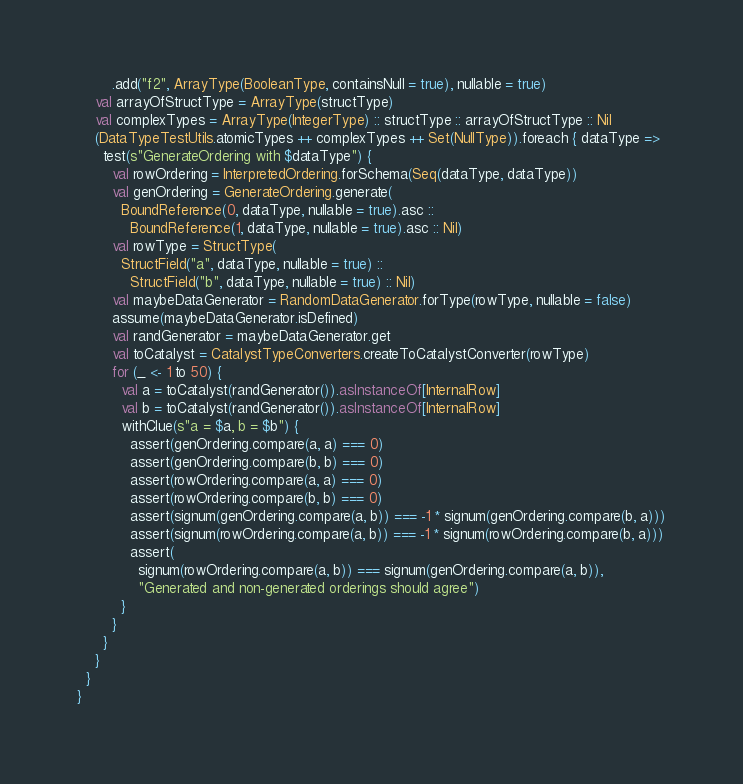<code> <loc_0><loc_0><loc_500><loc_500><_Scala_>        .add("f2", ArrayType(BooleanType, containsNull = true), nullable = true)
    val arrayOfStructType = ArrayType(structType)
    val complexTypes = ArrayType(IntegerType) :: structType :: arrayOfStructType :: Nil
    (DataTypeTestUtils.atomicTypes ++ complexTypes ++ Set(NullType)).foreach { dataType =>
      test(s"GenerateOrdering with $dataType") {
        val rowOrdering = InterpretedOrdering.forSchema(Seq(dataType, dataType))
        val genOrdering = GenerateOrdering.generate(
          BoundReference(0, dataType, nullable = true).asc ::
            BoundReference(1, dataType, nullable = true).asc :: Nil)
        val rowType = StructType(
          StructField("a", dataType, nullable = true) ::
            StructField("b", dataType, nullable = true) :: Nil)
        val maybeDataGenerator = RandomDataGenerator.forType(rowType, nullable = false)
        assume(maybeDataGenerator.isDefined)
        val randGenerator = maybeDataGenerator.get
        val toCatalyst = CatalystTypeConverters.createToCatalystConverter(rowType)
        for (_ <- 1 to 50) {
          val a = toCatalyst(randGenerator()).asInstanceOf[InternalRow]
          val b = toCatalyst(randGenerator()).asInstanceOf[InternalRow]
          withClue(s"a = $a, b = $b") {
            assert(genOrdering.compare(a, a) === 0)
            assert(genOrdering.compare(b, b) === 0)
            assert(rowOrdering.compare(a, a) === 0)
            assert(rowOrdering.compare(b, b) === 0)
            assert(signum(genOrdering.compare(a, b)) === -1 * signum(genOrdering.compare(b, a)))
            assert(signum(rowOrdering.compare(a, b)) === -1 * signum(rowOrdering.compare(b, a)))
            assert(
              signum(rowOrdering.compare(a, b)) === signum(genOrdering.compare(a, b)),
              "Generated and non-generated orderings should agree")
          }
        }
      }
    }
  }
}
</code> 